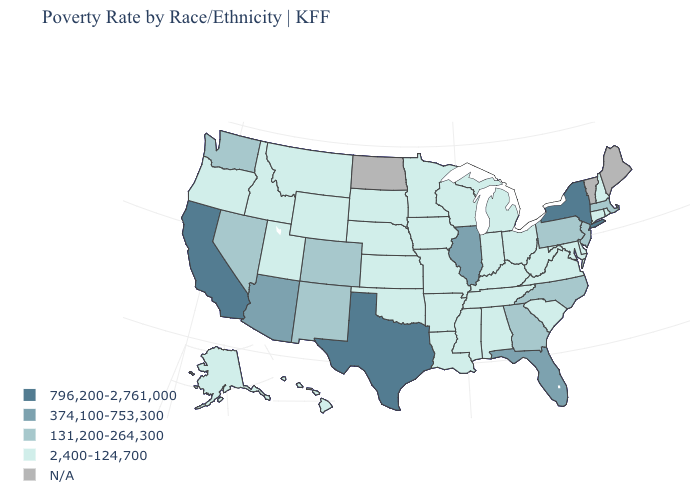Which states have the lowest value in the USA?
Be succinct. Alabama, Alaska, Arkansas, Connecticut, Delaware, Hawaii, Idaho, Indiana, Iowa, Kansas, Kentucky, Louisiana, Maryland, Michigan, Minnesota, Mississippi, Missouri, Montana, Nebraska, New Hampshire, Ohio, Oklahoma, Oregon, Rhode Island, South Carolina, South Dakota, Tennessee, Utah, Virginia, West Virginia, Wisconsin, Wyoming. How many symbols are there in the legend?
Answer briefly. 5. Name the states that have a value in the range 796,200-2,761,000?
Short answer required. California, New York, Texas. Which states have the highest value in the USA?
Answer briefly. California, New York, Texas. Does California have the highest value in the West?
Short answer required. Yes. What is the lowest value in states that border Idaho?
Answer briefly. 2,400-124,700. Does California have the highest value in the West?
Be succinct. Yes. What is the value of West Virginia?
Give a very brief answer. 2,400-124,700. Among the states that border New York , does Connecticut have the lowest value?
Write a very short answer. Yes. Does Texas have the highest value in the South?
Keep it brief. Yes. What is the value of Delaware?
Be succinct. 2,400-124,700. Among the states that border Arizona , does Utah have the highest value?
Give a very brief answer. No. Among the states that border Pennsylvania , does West Virginia have the lowest value?
Quick response, please. Yes. What is the value of Kansas?
Concise answer only. 2,400-124,700. Does Nevada have the lowest value in the West?
Quick response, please. No. 